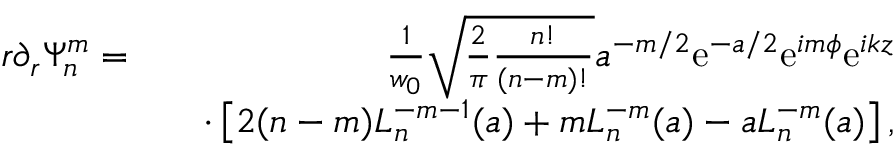Convert formula to latex. <formula><loc_0><loc_0><loc_500><loc_500>\begin{array} { r l r } { r \partial _ { r } \Psi _ { n } ^ { m } = } & { \frac { 1 } { w _ { 0 } } \sqrt { \frac { 2 } { \pi } \frac { n ! } { ( n - m ) ! } } a ^ { - m / 2 } e ^ { - a / 2 } e ^ { i m \phi } e ^ { i k z } } \\ & { \cdot \left [ 2 ( n - m ) L _ { n } ^ { - m - 1 } ( a ) + m L _ { n } ^ { - m } ( a ) - a L _ { n } ^ { - m } ( a ) \right ] , } \end{array}</formula> 